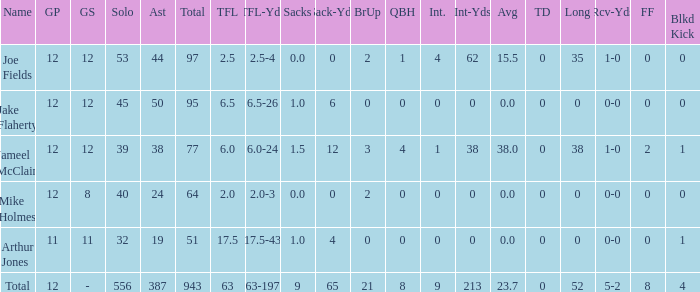How many tackle assists for the player who averages 23.7? 387.0. 